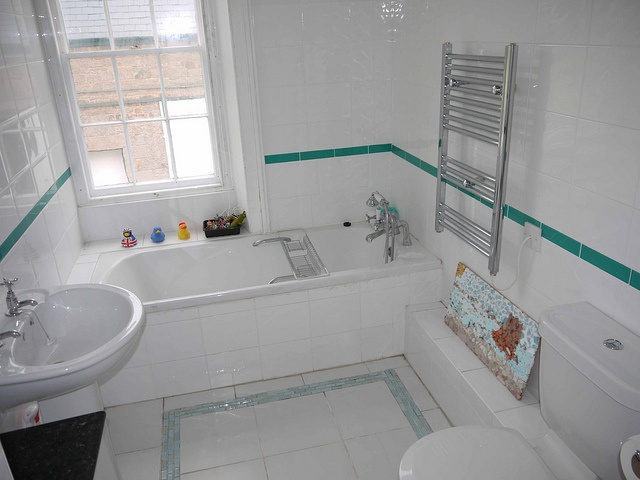Describe the objects in this image and their specific colors. I can see sink in gray, darkgray, and lightgray tones and toilet in gray, darkgray, and lightgray tones in this image. 